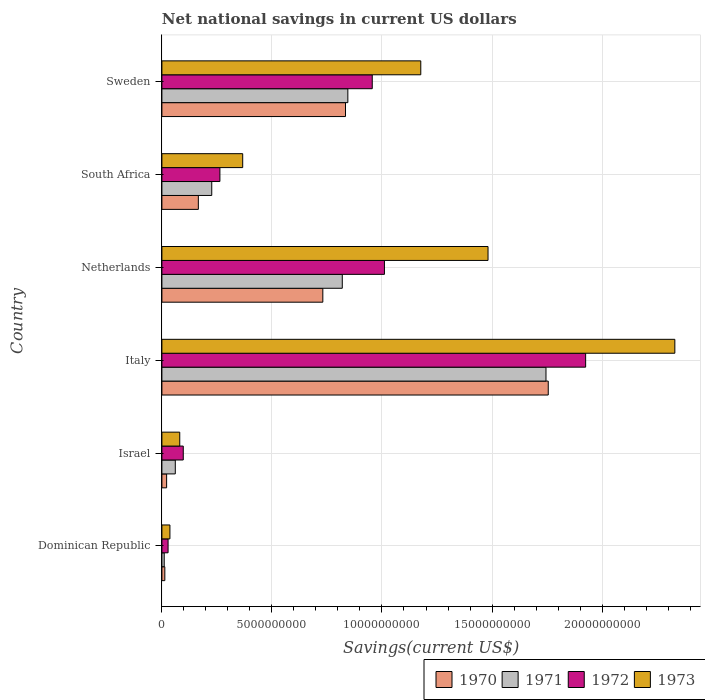How many groups of bars are there?
Offer a very short reply. 6. Are the number of bars on each tick of the Y-axis equal?
Provide a succinct answer. Yes. How many bars are there on the 1st tick from the top?
Give a very brief answer. 4. How many bars are there on the 2nd tick from the bottom?
Offer a very short reply. 4. In how many cases, is the number of bars for a given country not equal to the number of legend labels?
Keep it short and to the point. 0. What is the net national savings in 1973 in South Africa?
Provide a succinct answer. 3.67e+09. Across all countries, what is the maximum net national savings in 1970?
Your answer should be compact. 1.76e+1. Across all countries, what is the minimum net national savings in 1972?
Your answer should be very brief. 2.80e+08. In which country was the net national savings in 1971 minimum?
Your answer should be compact. Dominican Republic. What is the total net national savings in 1971 in the graph?
Provide a short and direct response. 3.71e+1. What is the difference between the net national savings in 1973 in Italy and that in Netherlands?
Keep it short and to the point. 8.49e+09. What is the difference between the net national savings in 1970 in Italy and the net national savings in 1971 in South Africa?
Provide a succinct answer. 1.53e+1. What is the average net national savings in 1972 per country?
Offer a terse response. 7.14e+09. What is the difference between the net national savings in 1970 and net national savings in 1972 in Israel?
Your answer should be compact. -7.56e+08. In how many countries, is the net national savings in 1970 greater than 23000000000 US$?
Offer a very short reply. 0. What is the ratio of the net national savings in 1972 in Italy to that in Netherlands?
Give a very brief answer. 1.9. What is the difference between the highest and the second highest net national savings in 1973?
Offer a very short reply. 8.49e+09. What is the difference between the highest and the lowest net national savings in 1972?
Offer a terse response. 1.90e+1. What does the 3rd bar from the top in Israel represents?
Provide a short and direct response. 1971. How many bars are there?
Keep it short and to the point. 24. How many countries are there in the graph?
Offer a very short reply. 6. Are the values on the major ticks of X-axis written in scientific E-notation?
Offer a very short reply. No. Does the graph contain grids?
Offer a very short reply. Yes. How many legend labels are there?
Make the answer very short. 4. How are the legend labels stacked?
Make the answer very short. Horizontal. What is the title of the graph?
Your answer should be compact. Net national savings in current US dollars. Does "1964" appear as one of the legend labels in the graph?
Your answer should be very brief. No. What is the label or title of the X-axis?
Offer a very short reply. Savings(current US$). What is the label or title of the Y-axis?
Your answer should be very brief. Country. What is the Savings(current US$) in 1970 in Dominican Republic?
Offer a very short reply. 1.33e+08. What is the Savings(current US$) of 1971 in Dominican Republic?
Your response must be concise. 1.05e+08. What is the Savings(current US$) of 1972 in Dominican Republic?
Your answer should be very brief. 2.80e+08. What is the Savings(current US$) in 1973 in Dominican Republic?
Provide a succinct answer. 3.65e+08. What is the Savings(current US$) of 1970 in Israel?
Your answer should be very brief. 2.15e+08. What is the Savings(current US$) in 1971 in Israel?
Offer a terse response. 6.09e+08. What is the Savings(current US$) of 1972 in Israel?
Ensure brevity in your answer.  9.71e+08. What is the Savings(current US$) in 1973 in Israel?
Offer a very short reply. 8.11e+08. What is the Savings(current US$) of 1970 in Italy?
Make the answer very short. 1.76e+1. What is the Savings(current US$) of 1971 in Italy?
Provide a short and direct response. 1.75e+1. What is the Savings(current US$) of 1972 in Italy?
Provide a succinct answer. 1.93e+1. What is the Savings(current US$) of 1973 in Italy?
Provide a succinct answer. 2.33e+1. What is the Savings(current US$) of 1970 in Netherlands?
Your response must be concise. 7.31e+09. What is the Savings(current US$) in 1971 in Netherlands?
Give a very brief answer. 8.20e+09. What is the Savings(current US$) of 1972 in Netherlands?
Make the answer very short. 1.01e+1. What is the Savings(current US$) of 1973 in Netherlands?
Make the answer very short. 1.48e+1. What is the Savings(current US$) of 1970 in South Africa?
Give a very brief answer. 1.66e+09. What is the Savings(current US$) of 1971 in South Africa?
Ensure brevity in your answer.  2.27e+09. What is the Savings(current US$) of 1972 in South Africa?
Provide a succinct answer. 2.64e+09. What is the Savings(current US$) in 1973 in South Africa?
Keep it short and to the point. 3.67e+09. What is the Savings(current US$) of 1970 in Sweden?
Keep it short and to the point. 8.34e+09. What is the Savings(current US$) of 1971 in Sweden?
Provide a short and direct response. 8.45e+09. What is the Savings(current US$) of 1972 in Sweden?
Your response must be concise. 9.56e+09. What is the Savings(current US$) in 1973 in Sweden?
Your answer should be compact. 1.18e+1. Across all countries, what is the maximum Savings(current US$) of 1970?
Keep it short and to the point. 1.76e+1. Across all countries, what is the maximum Savings(current US$) in 1971?
Provide a short and direct response. 1.75e+1. Across all countries, what is the maximum Savings(current US$) in 1972?
Provide a short and direct response. 1.93e+1. Across all countries, what is the maximum Savings(current US$) in 1973?
Keep it short and to the point. 2.33e+1. Across all countries, what is the minimum Savings(current US$) in 1970?
Offer a very short reply. 1.33e+08. Across all countries, what is the minimum Savings(current US$) of 1971?
Give a very brief answer. 1.05e+08. Across all countries, what is the minimum Savings(current US$) of 1972?
Your answer should be compact. 2.80e+08. Across all countries, what is the minimum Savings(current US$) of 1973?
Keep it short and to the point. 3.65e+08. What is the total Savings(current US$) of 1970 in the graph?
Give a very brief answer. 3.52e+1. What is the total Savings(current US$) in 1971 in the graph?
Provide a short and direct response. 3.71e+1. What is the total Savings(current US$) of 1972 in the graph?
Provide a short and direct response. 4.28e+1. What is the total Savings(current US$) of 1973 in the graph?
Offer a terse response. 5.47e+1. What is the difference between the Savings(current US$) in 1970 in Dominican Republic and that in Israel?
Give a very brief answer. -8.19e+07. What is the difference between the Savings(current US$) of 1971 in Dominican Republic and that in Israel?
Your answer should be very brief. -5.03e+08. What is the difference between the Savings(current US$) of 1972 in Dominican Republic and that in Israel?
Keep it short and to the point. -6.90e+08. What is the difference between the Savings(current US$) in 1973 in Dominican Republic and that in Israel?
Your answer should be compact. -4.46e+08. What is the difference between the Savings(current US$) in 1970 in Dominican Republic and that in Italy?
Make the answer very short. -1.74e+1. What is the difference between the Savings(current US$) in 1971 in Dominican Republic and that in Italy?
Ensure brevity in your answer.  -1.73e+1. What is the difference between the Savings(current US$) in 1972 in Dominican Republic and that in Italy?
Make the answer very short. -1.90e+1. What is the difference between the Savings(current US$) of 1973 in Dominican Republic and that in Italy?
Offer a terse response. -2.29e+1. What is the difference between the Savings(current US$) of 1970 in Dominican Republic and that in Netherlands?
Give a very brief answer. -7.18e+09. What is the difference between the Savings(current US$) in 1971 in Dominican Republic and that in Netherlands?
Provide a short and direct response. -8.09e+09. What is the difference between the Savings(current US$) of 1972 in Dominican Republic and that in Netherlands?
Your response must be concise. -9.83e+09. What is the difference between the Savings(current US$) in 1973 in Dominican Republic and that in Netherlands?
Ensure brevity in your answer.  -1.45e+1. What is the difference between the Savings(current US$) in 1970 in Dominican Republic and that in South Africa?
Your answer should be very brief. -1.52e+09. What is the difference between the Savings(current US$) in 1971 in Dominican Republic and that in South Africa?
Provide a short and direct response. -2.16e+09. What is the difference between the Savings(current US$) of 1972 in Dominican Republic and that in South Africa?
Ensure brevity in your answer.  -2.35e+09. What is the difference between the Savings(current US$) of 1973 in Dominican Republic and that in South Africa?
Make the answer very short. -3.31e+09. What is the difference between the Savings(current US$) of 1970 in Dominican Republic and that in Sweden?
Provide a succinct answer. -8.21e+09. What is the difference between the Savings(current US$) of 1971 in Dominican Republic and that in Sweden?
Ensure brevity in your answer.  -8.34e+09. What is the difference between the Savings(current US$) of 1972 in Dominican Republic and that in Sweden?
Your response must be concise. -9.28e+09. What is the difference between the Savings(current US$) in 1973 in Dominican Republic and that in Sweden?
Provide a succinct answer. -1.14e+1. What is the difference between the Savings(current US$) in 1970 in Israel and that in Italy?
Your response must be concise. -1.73e+1. What is the difference between the Savings(current US$) of 1971 in Israel and that in Italy?
Your answer should be very brief. -1.68e+1. What is the difference between the Savings(current US$) of 1972 in Israel and that in Italy?
Make the answer very short. -1.83e+1. What is the difference between the Savings(current US$) in 1973 in Israel and that in Italy?
Your answer should be very brief. -2.25e+1. What is the difference between the Savings(current US$) in 1970 in Israel and that in Netherlands?
Make the answer very short. -7.10e+09. What is the difference between the Savings(current US$) of 1971 in Israel and that in Netherlands?
Offer a terse response. -7.59e+09. What is the difference between the Savings(current US$) of 1972 in Israel and that in Netherlands?
Your answer should be very brief. -9.14e+09. What is the difference between the Savings(current US$) of 1973 in Israel and that in Netherlands?
Provide a succinct answer. -1.40e+1. What is the difference between the Savings(current US$) of 1970 in Israel and that in South Africa?
Ensure brevity in your answer.  -1.44e+09. What is the difference between the Savings(current US$) of 1971 in Israel and that in South Africa?
Ensure brevity in your answer.  -1.66e+09. What is the difference between the Savings(current US$) in 1972 in Israel and that in South Africa?
Keep it short and to the point. -1.66e+09. What is the difference between the Savings(current US$) in 1973 in Israel and that in South Africa?
Keep it short and to the point. -2.86e+09. What is the difference between the Savings(current US$) of 1970 in Israel and that in Sweden?
Provide a succinct answer. -8.13e+09. What is the difference between the Savings(current US$) in 1971 in Israel and that in Sweden?
Provide a short and direct response. -7.84e+09. What is the difference between the Savings(current US$) in 1972 in Israel and that in Sweden?
Keep it short and to the point. -8.59e+09. What is the difference between the Savings(current US$) of 1973 in Israel and that in Sweden?
Provide a succinct answer. -1.10e+1. What is the difference between the Savings(current US$) in 1970 in Italy and that in Netherlands?
Provide a short and direct response. 1.02e+1. What is the difference between the Savings(current US$) of 1971 in Italy and that in Netherlands?
Provide a succinct answer. 9.26e+09. What is the difference between the Savings(current US$) in 1972 in Italy and that in Netherlands?
Offer a very short reply. 9.14e+09. What is the difference between the Savings(current US$) of 1973 in Italy and that in Netherlands?
Make the answer very short. 8.49e+09. What is the difference between the Savings(current US$) in 1970 in Italy and that in South Africa?
Offer a very short reply. 1.59e+1. What is the difference between the Savings(current US$) in 1971 in Italy and that in South Africa?
Your response must be concise. 1.52e+1. What is the difference between the Savings(current US$) in 1972 in Italy and that in South Africa?
Ensure brevity in your answer.  1.66e+1. What is the difference between the Savings(current US$) in 1973 in Italy and that in South Africa?
Give a very brief answer. 1.96e+1. What is the difference between the Savings(current US$) of 1970 in Italy and that in Sweden?
Offer a very short reply. 9.21e+09. What is the difference between the Savings(current US$) of 1971 in Italy and that in Sweden?
Your answer should be very brief. 9.00e+09. What is the difference between the Savings(current US$) in 1972 in Italy and that in Sweden?
Provide a short and direct response. 9.70e+09. What is the difference between the Savings(current US$) in 1973 in Italy and that in Sweden?
Your response must be concise. 1.15e+1. What is the difference between the Savings(current US$) of 1970 in Netherlands and that in South Africa?
Offer a very short reply. 5.66e+09. What is the difference between the Savings(current US$) of 1971 in Netherlands and that in South Africa?
Ensure brevity in your answer.  5.93e+09. What is the difference between the Savings(current US$) of 1972 in Netherlands and that in South Africa?
Offer a very short reply. 7.48e+09. What is the difference between the Savings(current US$) of 1973 in Netherlands and that in South Africa?
Provide a short and direct response. 1.11e+1. What is the difference between the Savings(current US$) of 1970 in Netherlands and that in Sweden?
Provide a short and direct response. -1.03e+09. What is the difference between the Savings(current US$) of 1971 in Netherlands and that in Sweden?
Your response must be concise. -2.53e+08. What is the difference between the Savings(current US$) of 1972 in Netherlands and that in Sweden?
Provide a short and direct response. 5.54e+08. What is the difference between the Savings(current US$) in 1973 in Netherlands and that in Sweden?
Provide a short and direct response. 3.06e+09. What is the difference between the Savings(current US$) in 1970 in South Africa and that in Sweden?
Make the answer very short. -6.69e+09. What is the difference between the Savings(current US$) in 1971 in South Africa and that in Sweden?
Your answer should be compact. -6.18e+09. What is the difference between the Savings(current US$) in 1972 in South Africa and that in Sweden?
Provide a short and direct response. -6.92e+09. What is the difference between the Savings(current US$) in 1973 in South Africa and that in Sweden?
Your answer should be compact. -8.09e+09. What is the difference between the Savings(current US$) of 1970 in Dominican Republic and the Savings(current US$) of 1971 in Israel?
Offer a very short reply. -4.76e+08. What is the difference between the Savings(current US$) in 1970 in Dominican Republic and the Savings(current US$) in 1972 in Israel?
Make the answer very short. -8.38e+08. What is the difference between the Savings(current US$) of 1970 in Dominican Republic and the Savings(current US$) of 1973 in Israel?
Your response must be concise. -6.78e+08. What is the difference between the Savings(current US$) in 1971 in Dominican Republic and the Savings(current US$) in 1972 in Israel?
Ensure brevity in your answer.  -8.65e+08. What is the difference between the Savings(current US$) of 1971 in Dominican Republic and the Savings(current US$) of 1973 in Israel?
Your response must be concise. -7.05e+08. What is the difference between the Savings(current US$) of 1972 in Dominican Republic and the Savings(current US$) of 1973 in Israel?
Offer a terse response. -5.30e+08. What is the difference between the Savings(current US$) in 1970 in Dominican Republic and the Savings(current US$) in 1971 in Italy?
Keep it short and to the point. -1.73e+1. What is the difference between the Savings(current US$) in 1970 in Dominican Republic and the Savings(current US$) in 1972 in Italy?
Keep it short and to the point. -1.91e+1. What is the difference between the Savings(current US$) of 1970 in Dominican Republic and the Savings(current US$) of 1973 in Italy?
Offer a very short reply. -2.32e+1. What is the difference between the Savings(current US$) in 1971 in Dominican Republic and the Savings(current US$) in 1972 in Italy?
Your answer should be very brief. -1.91e+1. What is the difference between the Savings(current US$) in 1971 in Dominican Republic and the Savings(current US$) in 1973 in Italy?
Give a very brief answer. -2.32e+1. What is the difference between the Savings(current US$) of 1972 in Dominican Republic and the Savings(current US$) of 1973 in Italy?
Provide a short and direct response. -2.30e+1. What is the difference between the Savings(current US$) in 1970 in Dominican Republic and the Savings(current US$) in 1971 in Netherlands?
Give a very brief answer. -8.06e+09. What is the difference between the Savings(current US$) in 1970 in Dominican Republic and the Savings(current US$) in 1972 in Netherlands?
Offer a terse response. -9.98e+09. What is the difference between the Savings(current US$) of 1970 in Dominican Republic and the Savings(current US$) of 1973 in Netherlands?
Your response must be concise. -1.47e+1. What is the difference between the Savings(current US$) of 1971 in Dominican Republic and the Savings(current US$) of 1972 in Netherlands?
Give a very brief answer. -1.00e+1. What is the difference between the Savings(current US$) in 1971 in Dominican Republic and the Savings(current US$) in 1973 in Netherlands?
Provide a succinct answer. -1.47e+1. What is the difference between the Savings(current US$) of 1972 in Dominican Republic and the Savings(current US$) of 1973 in Netherlands?
Provide a short and direct response. -1.45e+1. What is the difference between the Savings(current US$) in 1970 in Dominican Republic and the Savings(current US$) in 1971 in South Africa?
Provide a succinct answer. -2.13e+09. What is the difference between the Savings(current US$) of 1970 in Dominican Republic and the Savings(current US$) of 1972 in South Africa?
Offer a very short reply. -2.50e+09. What is the difference between the Savings(current US$) of 1970 in Dominican Republic and the Savings(current US$) of 1973 in South Africa?
Make the answer very short. -3.54e+09. What is the difference between the Savings(current US$) of 1971 in Dominican Republic and the Savings(current US$) of 1972 in South Africa?
Offer a very short reply. -2.53e+09. What is the difference between the Savings(current US$) of 1971 in Dominican Republic and the Savings(current US$) of 1973 in South Africa?
Offer a terse response. -3.57e+09. What is the difference between the Savings(current US$) in 1972 in Dominican Republic and the Savings(current US$) in 1973 in South Africa?
Provide a short and direct response. -3.39e+09. What is the difference between the Savings(current US$) of 1970 in Dominican Republic and the Savings(current US$) of 1971 in Sweden?
Ensure brevity in your answer.  -8.32e+09. What is the difference between the Savings(current US$) in 1970 in Dominican Republic and the Savings(current US$) in 1972 in Sweden?
Make the answer very short. -9.43e+09. What is the difference between the Savings(current US$) in 1970 in Dominican Republic and the Savings(current US$) in 1973 in Sweden?
Provide a succinct answer. -1.16e+1. What is the difference between the Savings(current US$) in 1971 in Dominican Republic and the Savings(current US$) in 1972 in Sweden?
Offer a very short reply. -9.45e+09. What is the difference between the Savings(current US$) in 1971 in Dominican Republic and the Savings(current US$) in 1973 in Sweden?
Your response must be concise. -1.17e+1. What is the difference between the Savings(current US$) in 1972 in Dominican Republic and the Savings(current US$) in 1973 in Sweden?
Your answer should be compact. -1.15e+1. What is the difference between the Savings(current US$) in 1970 in Israel and the Savings(current US$) in 1971 in Italy?
Provide a succinct answer. -1.72e+1. What is the difference between the Savings(current US$) in 1970 in Israel and the Savings(current US$) in 1972 in Italy?
Your answer should be compact. -1.90e+1. What is the difference between the Savings(current US$) of 1970 in Israel and the Savings(current US$) of 1973 in Italy?
Ensure brevity in your answer.  -2.31e+1. What is the difference between the Savings(current US$) in 1971 in Israel and the Savings(current US$) in 1972 in Italy?
Your answer should be very brief. -1.86e+1. What is the difference between the Savings(current US$) of 1971 in Israel and the Savings(current US$) of 1973 in Italy?
Provide a succinct answer. -2.27e+1. What is the difference between the Savings(current US$) of 1972 in Israel and the Savings(current US$) of 1973 in Italy?
Provide a short and direct response. -2.23e+1. What is the difference between the Savings(current US$) in 1970 in Israel and the Savings(current US$) in 1971 in Netherlands?
Ensure brevity in your answer.  -7.98e+09. What is the difference between the Savings(current US$) in 1970 in Israel and the Savings(current US$) in 1972 in Netherlands?
Your response must be concise. -9.90e+09. What is the difference between the Savings(current US$) in 1970 in Israel and the Savings(current US$) in 1973 in Netherlands?
Offer a very short reply. -1.46e+1. What is the difference between the Savings(current US$) in 1971 in Israel and the Savings(current US$) in 1972 in Netherlands?
Ensure brevity in your answer.  -9.50e+09. What is the difference between the Savings(current US$) in 1971 in Israel and the Savings(current US$) in 1973 in Netherlands?
Ensure brevity in your answer.  -1.42e+1. What is the difference between the Savings(current US$) of 1972 in Israel and the Savings(current US$) of 1973 in Netherlands?
Ensure brevity in your answer.  -1.38e+1. What is the difference between the Savings(current US$) of 1970 in Israel and the Savings(current US$) of 1971 in South Africa?
Keep it short and to the point. -2.05e+09. What is the difference between the Savings(current US$) of 1970 in Israel and the Savings(current US$) of 1972 in South Africa?
Your response must be concise. -2.42e+09. What is the difference between the Savings(current US$) of 1970 in Israel and the Savings(current US$) of 1973 in South Africa?
Make the answer very short. -3.46e+09. What is the difference between the Savings(current US$) of 1971 in Israel and the Savings(current US$) of 1972 in South Africa?
Give a very brief answer. -2.03e+09. What is the difference between the Savings(current US$) in 1971 in Israel and the Savings(current US$) in 1973 in South Africa?
Give a very brief answer. -3.06e+09. What is the difference between the Savings(current US$) of 1972 in Israel and the Savings(current US$) of 1973 in South Africa?
Your answer should be very brief. -2.70e+09. What is the difference between the Savings(current US$) of 1970 in Israel and the Savings(current US$) of 1971 in Sweden?
Provide a succinct answer. -8.23e+09. What is the difference between the Savings(current US$) in 1970 in Israel and the Savings(current US$) in 1972 in Sweden?
Provide a succinct answer. -9.34e+09. What is the difference between the Savings(current US$) of 1970 in Israel and the Savings(current US$) of 1973 in Sweden?
Your response must be concise. -1.15e+1. What is the difference between the Savings(current US$) in 1971 in Israel and the Savings(current US$) in 1972 in Sweden?
Your response must be concise. -8.95e+09. What is the difference between the Savings(current US$) of 1971 in Israel and the Savings(current US$) of 1973 in Sweden?
Offer a terse response. -1.12e+1. What is the difference between the Savings(current US$) of 1972 in Israel and the Savings(current US$) of 1973 in Sweden?
Offer a terse response. -1.08e+1. What is the difference between the Savings(current US$) in 1970 in Italy and the Savings(current US$) in 1971 in Netherlands?
Give a very brief answer. 9.36e+09. What is the difference between the Savings(current US$) of 1970 in Italy and the Savings(current US$) of 1972 in Netherlands?
Provide a succinct answer. 7.44e+09. What is the difference between the Savings(current US$) in 1970 in Italy and the Savings(current US$) in 1973 in Netherlands?
Give a very brief answer. 2.74e+09. What is the difference between the Savings(current US$) in 1971 in Italy and the Savings(current US$) in 1972 in Netherlands?
Ensure brevity in your answer.  7.34e+09. What is the difference between the Savings(current US$) in 1971 in Italy and the Savings(current US$) in 1973 in Netherlands?
Give a very brief answer. 2.63e+09. What is the difference between the Savings(current US$) of 1972 in Italy and the Savings(current US$) of 1973 in Netherlands?
Offer a terse response. 4.44e+09. What is the difference between the Savings(current US$) of 1970 in Italy and the Savings(current US$) of 1971 in South Africa?
Keep it short and to the point. 1.53e+1. What is the difference between the Savings(current US$) in 1970 in Italy and the Savings(current US$) in 1972 in South Africa?
Your answer should be compact. 1.49e+1. What is the difference between the Savings(current US$) of 1970 in Italy and the Savings(current US$) of 1973 in South Africa?
Provide a short and direct response. 1.39e+1. What is the difference between the Savings(current US$) of 1971 in Italy and the Savings(current US$) of 1972 in South Africa?
Your answer should be compact. 1.48e+1. What is the difference between the Savings(current US$) in 1971 in Italy and the Savings(current US$) in 1973 in South Africa?
Your answer should be compact. 1.38e+1. What is the difference between the Savings(current US$) of 1972 in Italy and the Savings(current US$) of 1973 in South Africa?
Provide a short and direct response. 1.56e+1. What is the difference between the Savings(current US$) in 1970 in Italy and the Savings(current US$) in 1971 in Sweden?
Keep it short and to the point. 9.11e+09. What is the difference between the Savings(current US$) in 1970 in Italy and the Savings(current US$) in 1972 in Sweden?
Your answer should be compact. 8.00e+09. What is the difference between the Savings(current US$) of 1970 in Italy and the Savings(current US$) of 1973 in Sweden?
Provide a short and direct response. 5.79e+09. What is the difference between the Savings(current US$) of 1971 in Italy and the Savings(current US$) of 1972 in Sweden?
Offer a terse response. 7.89e+09. What is the difference between the Savings(current US$) of 1971 in Italy and the Savings(current US$) of 1973 in Sweden?
Ensure brevity in your answer.  5.69e+09. What is the difference between the Savings(current US$) in 1972 in Italy and the Savings(current US$) in 1973 in Sweden?
Provide a short and direct response. 7.49e+09. What is the difference between the Savings(current US$) in 1970 in Netherlands and the Savings(current US$) in 1971 in South Africa?
Offer a very short reply. 5.05e+09. What is the difference between the Savings(current US$) of 1970 in Netherlands and the Savings(current US$) of 1972 in South Africa?
Give a very brief answer. 4.68e+09. What is the difference between the Savings(current US$) of 1970 in Netherlands and the Savings(current US$) of 1973 in South Africa?
Provide a short and direct response. 3.64e+09. What is the difference between the Savings(current US$) of 1971 in Netherlands and the Savings(current US$) of 1972 in South Africa?
Keep it short and to the point. 5.56e+09. What is the difference between the Savings(current US$) in 1971 in Netherlands and the Savings(current US$) in 1973 in South Africa?
Offer a very short reply. 4.52e+09. What is the difference between the Savings(current US$) in 1972 in Netherlands and the Savings(current US$) in 1973 in South Africa?
Make the answer very short. 6.44e+09. What is the difference between the Savings(current US$) in 1970 in Netherlands and the Savings(current US$) in 1971 in Sweden?
Your answer should be compact. -1.14e+09. What is the difference between the Savings(current US$) of 1970 in Netherlands and the Savings(current US$) of 1972 in Sweden?
Keep it short and to the point. -2.25e+09. What is the difference between the Savings(current US$) of 1970 in Netherlands and the Savings(current US$) of 1973 in Sweden?
Provide a succinct answer. -4.45e+09. What is the difference between the Savings(current US$) in 1971 in Netherlands and the Savings(current US$) in 1972 in Sweden?
Your answer should be compact. -1.36e+09. What is the difference between the Savings(current US$) in 1971 in Netherlands and the Savings(current US$) in 1973 in Sweden?
Give a very brief answer. -3.57e+09. What is the difference between the Savings(current US$) in 1972 in Netherlands and the Savings(current US$) in 1973 in Sweden?
Offer a terse response. -1.65e+09. What is the difference between the Savings(current US$) of 1970 in South Africa and the Savings(current US$) of 1971 in Sweden?
Make the answer very short. -6.79e+09. What is the difference between the Savings(current US$) of 1970 in South Africa and the Savings(current US$) of 1972 in Sweden?
Your answer should be compact. -7.90e+09. What is the difference between the Savings(current US$) in 1970 in South Africa and the Savings(current US$) in 1973 in Sweden?
Your answer should be compact. -1.01e+1. What is the difference between the Savings(current US$) of 1971 in South Africa and the Savings(current US$) of 1972 in Sweden?
Your answer should be very brief. -7.29e+09. What is the difference between the Savings(current US$) in 1971 in South Africa and the Savings(current US$) in 1973 in Sweden?
Provide a short and direct response. -9.50e+09. What is the difference between the Savings(current US$) in 1972 in South Africa and the Savings(current US$) in 1973 in Sweden?
Give a very brief answer. -9.13e+09. What is the average Savings(current US$) of 1970 per country?
Your answer should be compact. 5.87e+09. What is the average Savings(current US$) in 1971 per country?
Ensure brevity in your answer.  6.18e+09. What is the average Savings(current US$) of 1972 per country?
Ensure brevity in your answer.  7.14e+09. What is the average Savings(current US$) of 1973 per country?
Your answer should be very brief. 9.12e+09. What is the difference between the Savings(current US$) of 1970 and Savings(current US$) of 1971 in Dominican Republic?
Provide a short and direct response. 2.74e+07. What is the difference between the Savings(current US$) of 1970 and Savings(current US$) of 1972 in Dominican Republic?
Keep it short and to the point. -1.48e+08. What is the difference between the Savings(current US$) of 1970 and Savings(current US$) of 1973 in Dominican Republic?
Your answer should be very brief. -2.32e+08. What is the difference between the Savings(current US$) in 1971 and Savings(current US$) in 1972 in Dominican Republic?
Ensure brevity in your answer.  -1.75e+08. What is the difference between the Savings(current US$) of 1971 and Savings(current US$) of 1973 in Dominican Republic?
Your answer should be very brief. -2.59e+08. What is the difference between the Savings(current US$) of 1972 and Savings(current US$) of 1973 in Dominican Republic?
Offer a terse response. -8.40e+07. What is the difference between the Savings(current US$) in 1970 and Savings(current US$) in 1971 in Israel?
Ensure brevity in your answer.  -3.94e+08. What is the difference between the Savings(current US$) of 1970 and Savings(current US$) of 1972 in Israel?
Ensure brevity in your answer.  -7.56e+08. What is the difference between the Savings(current US$) in 1970 and Savings(current US$) in 1973 in Israel?
Your response must be concise. -5.96e+08. What is the difference between the Savings(current US$) of 1971 and Savings(current US$) of 1972 in Israel?
Make the answer very short. -3.62e+08. What is the difference between the Savings(current US$) in 1971 and Savings(current US$) in 1973 in Israel?
Make the answer very short. -2.02e+08. What is the difference between the Savings(current US$) in 1972 and Savings(current US$) in 1973 in Israel?
Your response must be concise. 1.60e+08. What is the difference between the Savings(current US$) of 1970 and Savings(current US$) of 1971 in Italy?
Give a very brief answer. 1.03e+08. What is the difference between the Savings(current US$) in 1970 and Savings(current US$) in 1972 in Italy?
Provide a succinct answer. -1.70e+09. What is the difference between the Savings(current US$) in 1970 and Savings(current US$) in 1973 in Italy?
Keep it short and to the point. -5.75e+09. What is the difference between the Savings(current US$) of 1971 and Savings(current US$) of 1972 in Italy?
Your answer should be compact. -1.80e+09. What is the difference between the Savings(current US$) of 1971 and Savings(current US$) of 1973 in Italy?
Your response must be concise. -5.86e+09. What is the difference between the Savings(current US$) of 1972 and Savings(current US$) of 1973 in Italy?
Your response must be concise. -4.05e+09. What is the difference between the Savings(current US$) in 1970 and Savings(current US$) in 1971 in Netherlands?
Your answer should be very brief. -8.83e+08. What is the difference between the Savings(current US$) of 1970 and Savings(current US$) of 1972 in Netherlands?
Your response must be concise. -2.80e+09. What is the difference between the Savings(current US$) of 1970 and Savings(current US$) of 1973 in Netherlands?
Offer a very short reply. -7.51e+09. What is the difference between the Savings(current US$) of 1971 and Savings(current US$) of 1972 in Netherlands?
Your answer should be very brief. -1.92e+09. What is the difference between the Savings(current US$) in 1971 and Savings(current US$) in 1973 in Netherlands?
Provide a short and direct response. -6.62e+09. What is the difference between the Savings(current US$) in 1972 and Savings(current US$) in 1973 in Netherlands?
Keep it short and to the point. -4.71e+09. What is the difference between the Savings(current US$) of 1970 and Savings(current US$) of 1971 in South Africa?
Your response must be concise. -6.09e+08. What is the difference between the Savings(current US$) in 1970 and Savings(current US$) in 1972 in South Africa?
Keep it short and to the point. -9.79e+08. What is the difference between the Savings(current US$) in 1970 and Savings(current US$) in 1973 in South Africa?
Your answer should be compact. -2.02e+09. What is the difference between the Savings(current US$) of 1971 and Savings(current US$) of 1972 in South Africa?
Give a very brief answer. -3.70e+08. What is the difference between the Savings(current US$) of 1971 and Savings(current US$) of 1973 in South Africa?
Keep it short and to the point. -1.41e+09. What is the difference between the Savings(current US$) in 1972 and Savings(current US$) in 1973 in South Africa?
Offer a terse response. -1.04e+09. What is the difference between the Savings(current US$) in 1970 and Savings(current US$) in 1971 in Sweden?
Give a very brief answer. -1.07e+08. What is the difference between the Savings(current US$) of 1970 and Savings(current US$) of 1972 in Sweden?
Provide a short and direct response. -1.22e+09. What is the difference between the Savings(current US$) in 1970 and Savings(current US$) in 1973 in Sweden?
Your response must be concise. -3.42e+09. What is the difference between the Savings(current US$) of 1971 and Savings(current US$) of 1972 in Sweden?
Your answer should be compact. -1.11e+09. What is the difference between the Savings(current US$) of 1971 and Savings(current US$) of 1973 in Sweden?
Make the answer very short. -3.31e+09. What is the difference between the Savings(current US$) in 1972 and Savings(current US$) in 1973 in Sweden?
Your answer should be compact. -2.20e+09. What is the ratio of the Savings(current US$) in 1970 in Dominican Republic to that in Israel?
Provide a succinct answer. 0.62. What is the ratio of the Savings(current US$) of 1971 in Dominican Republic to that in Israel?
Make the answer very short. 0.17. What is the ratio of the Savings(current US$) in 1972 in Dominican Republic to that in Israel?
Give a very brief answer. 0.29. What is the ratio of the Savings(current US$) in 1973 in Dominican Republic to that in Israel?
Your answer should be compact. 0.45. What is the ratio of the Savings(current US$) in 1970 in Dominican Republic to that in Italy?
Ensure brevity in your answer.  0.01. What is the ratio of the Savings(current US$) of 1971 in Dominican Republic to that in Italy?
Offer a very short reply. 0.01. What is the ratio of the Savings(current US$) in 1972 in Dominican Republic to that in Italy?
Ensure brevity in your answer.  0.01. What is the ratio of the Savings(current US$) of 1973 in Dominican Republic to that in Italy?
Keep it short and to the point. 0.02. What is the ratio of the Savings(current US$) in 1970 in Dominican Republic to that in Netherlands?
Provide a succinct answer. 0.02. What is the ratio of the Savings(current US$) in 1971 in Dominican Republic to that in Netherlands?
Offer a terse response. 0.01. What is the ratio of the Savings(current US$) in 1972 in Dominican Republic to that in Netherlands?
Make the answer very short. 0.03. What is the ratio of the Savings(current US$) in 1973 in Dominican Republic to that in Netherlands?
Make the answer very short. 0.02. What is the ratio of the Savings(current US$) of 1970 in Dominican Republic to that in South Africa?
Make the answer very short. 0.08. What is the ratio of the Savings(current US$) of 1971 in Dominican Republic to that in South Africa?
Provide a succinct answer. 0.05. What is the ratio of the Savings(current US$) in 1972 in Dominican Republic to that in South Africa?
Your answer should be very brief. 0.11. What is the ratio of the Savings(current US$) of 1973 in Dominican Republic to that in South Africa?
Offer a very short reply. 0.1. What is the ratio of the Savings(current US$) of 1970 in Dominican Republic to that in Sweden?
Your answer should be compact. 0.02. What is the ratio of the Savings(current US$) of 1971 in Dominican Republic to that in Sweden?
Your answer should be very brief. 0.01. What is the ratio of the Savings(current US$) of 1972 in Dominican Republic to that in Sweden?
Your answer should be very brief. 0.03. What is the ratio of the Savings(current US$) of 1973 in Dominican Republic to that in Sweden?
Offer a very short reply. 0.03. What is the ratio of the Savings(current US$) of 1970 in Israel to that in Italy?
Provide a short and direct response. 0.01. What is the ratio of the Savings(current US$) of 1971 in Israel to that in Italy?
Offer a very short reply. 0.03. What is the ratio of the Savings(current US$) of 1972 in Israel to that in Italy?
Your answer should be very brief. 0.05. What is the ratio of the Savings(current US$) in 1973 in Israel to that in Italy?
Provide a succinct answer. 0.03. What is the ratio of the Savings(current US$) in 1970 in Israel to that in Netherlands?
Your response must be concise. 0.03. What is the ratio of the Savings(current US$) in 1971 in Israel to that in Netherlands?
Your answer should be compact. 0.07. What is the ratio of the Savings(current US$) in 1972 in Israel to that in Netherlands?
Provide a short and direct response. 0.1. What is the ratio of the Savings(current US$) of 1973 in Israel to that in Netherlands?
Make the answer very short. 0.05. What is the ratio of the Savings(current US$) of 1970 in Israel to that in South Africa?
Offer a terse response. 0.13. What is the ratio of the Savings(current US$) in 1971 in Israel to that in South Africa?
Keep it short and to the point. 0.27. What is the ratio of the Savings(current US$) of 1972 in Israel to that in South Africa?
Offer a very short reply. 0.37. What is the ratio of the Savings(current US$) of 1973 in Israel to that in South Africa?
Your answer should be very brief. 0.22. What is the ratio of the Savings(current US$) of 1970 in Israel to that in Sweden?
Provide a short and direct response. 0.03. What is the ratio of the Savings(current US$) of 1971 in Israel to that in Sweden?
Give a very brief answer. 0.07. What is the ratio of the Savings(current US$) in 1972 in Israel to that in Sweden?
Make the answer very short. 0.1. What is the ratio of the Savings(current US$) in 1973 in Israel to that in Sweden?
Offer a very short reply. 0.07. What is the ratio of the Savings(current US$) of 1970 in Italy to that in Netherlands?
Give a very brief answer. 2.4. What is the ratio of the Savings(current US$) in 1971 in Italy to that in Netherlands?
Keep it short and to the point. 2.13. What is the ratio of the Savings(current US$) of 1972 in Italy to that in Netherlands?
Offer a very short reply. 1.9. What is the ratio of the Savings(current US$) of 1973 in Italy to that in Netherlands?
Make the answer very short. 1.57. What is the ratio of the Savings(current US$) of 1970 in Italy to that in South Africa?
Provide a short and direct response. 10.6. What is the ratio of the Savings(current US$) of 1971 in Italy to that in South Africa?
Make the answer very short. 7.7. What is the ratio of the Savings(current US$) of 1972 in Italy to that in South Africa?
Provide a succinct answer. 7.31. What is the ratio of the Savings(current US$) in 1973 in Italy to that in South Africa?
Your answer should be compact. 6.35. What is the ratio of the Savings(current US$) in 1970 in Italy to that in Sweden?
Give a very brief answer. 2.1. What is the ratio of the Savings(current US$) in 1971 in Italy to that in Sweden?
Make the answer very short. 2.07. What is the ratio of the Savings(current US$) of 1972 in Italy to that in Sweden?
Your answer should be compact. 2.01. What is the ratio of the Savings(current US$) in 1973 in Italy to that in Sweden?
Offer a terse response. 1.98. What is the ratio of the Savings(current US$) of 1970 in Netherlands to that in South Africa?
Give a very brief answer. 4.42. What is the ratio of the Savings(current US$) in 1971 in Netherlands to that in South Africa?
Keep it short and to the point. 3.62. What is the ratio of the Savings(current US$) in 1972 in Netherlands to that in South Africa?
Provide a short and direct response. 3.84. What is the ratio of the Savings(current US$) in 1973 in Netherlands to that in South Africa?
Offer a very short reply. 4.04. What is the ratio of the Savings(current US$) in 1970 in Netherlands to that in Sweden?
Provide a succinct answer. 0.88. What is the ratio of the Savings(current US$) of 1972 in Netherlands to that in Sweden?
Provide a succinct answer. 1.06. What is the ratio of the Savings(current US$) of 1973 in Netherlands to that in Sweden?
Your answer should be very brief. 1.26. What is the ratio of the Savings(current US$) in 1970 in South Africa to that in Sweden?
Give a very brief answer. 0.2. What is the ratio of the Savings(current US$) in 1971 in South Africa to that in Sweden?
Your answer should be very brief. 0.27. What is the ratio of the Savings(current US$) in 1972 in South Africa to that in Sweden?
Your response must be concise. 0.28. What is the ratio of the Savings(current US$) of 1973 in South Africa to that in Sweden?
Make the answer very short. 0.31. What is the difference between the highest and the second highest Savings(current US$) of 1970?
Provide a short and direct response. 9.21e+09. What is the difference between the highest and the second highest Savings(current US$) of 1971?
Offer a very short reply. 9.00e+09. What is the difference between the highest and the second highest Savings(current US$) in 1972?
Your answer should be very brief. 9.14e+09. What is the difference between the highest and the second highest Savings(current US$) in 1973?
Offer a terse response. 8.49e+09. What is the difference between the highest and the lowest Savings(current US$) in 1970?
Your answer should be very brief. 1.74e+1. What is the difference between the highest and the lowest Savings(current US$) of 1971?
Provide a succinct answer. 1.73e+1. What is the difference between the highest and the lowest Savings(current US$) of 1972?
Ensure brevity in your answer.  1.90e+1. What is the difference between the highest and the lowest Savings(current US$) in 1973?
Offer a very short reply. 2.29e+1. 